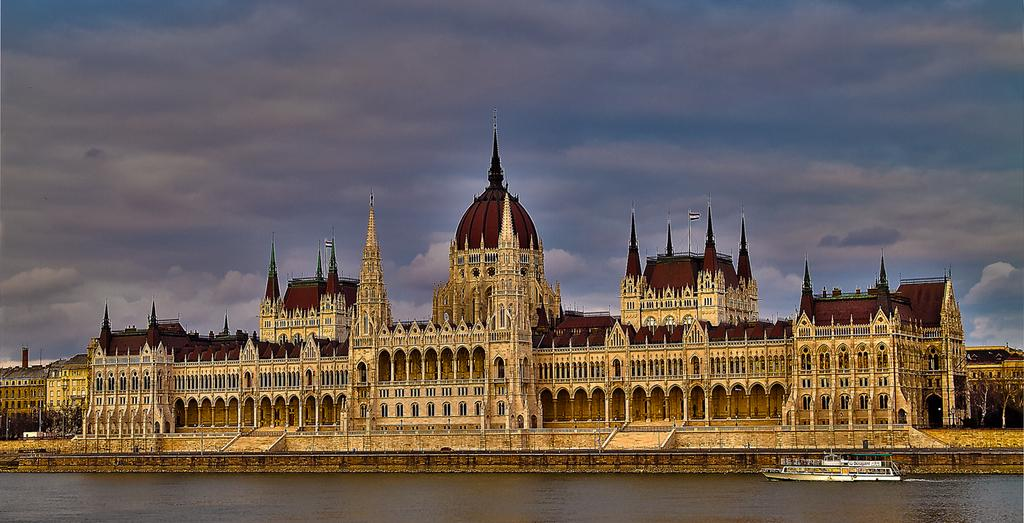What is the weather like in the image? The sky is cloudy in the image. What can be seen floating on the water? There is a ship floating on water in the image. What type of structures are visible in the image? There are buildings with windows in the image. What type of vegetation is present beside the buildings? Trees are present beside the buildings in the image. What type of net is being used to catch the crackers in the image? There is no net or crackers present in the image. What is the source of fear in the image? There is no fear or indication of fear in the image. 